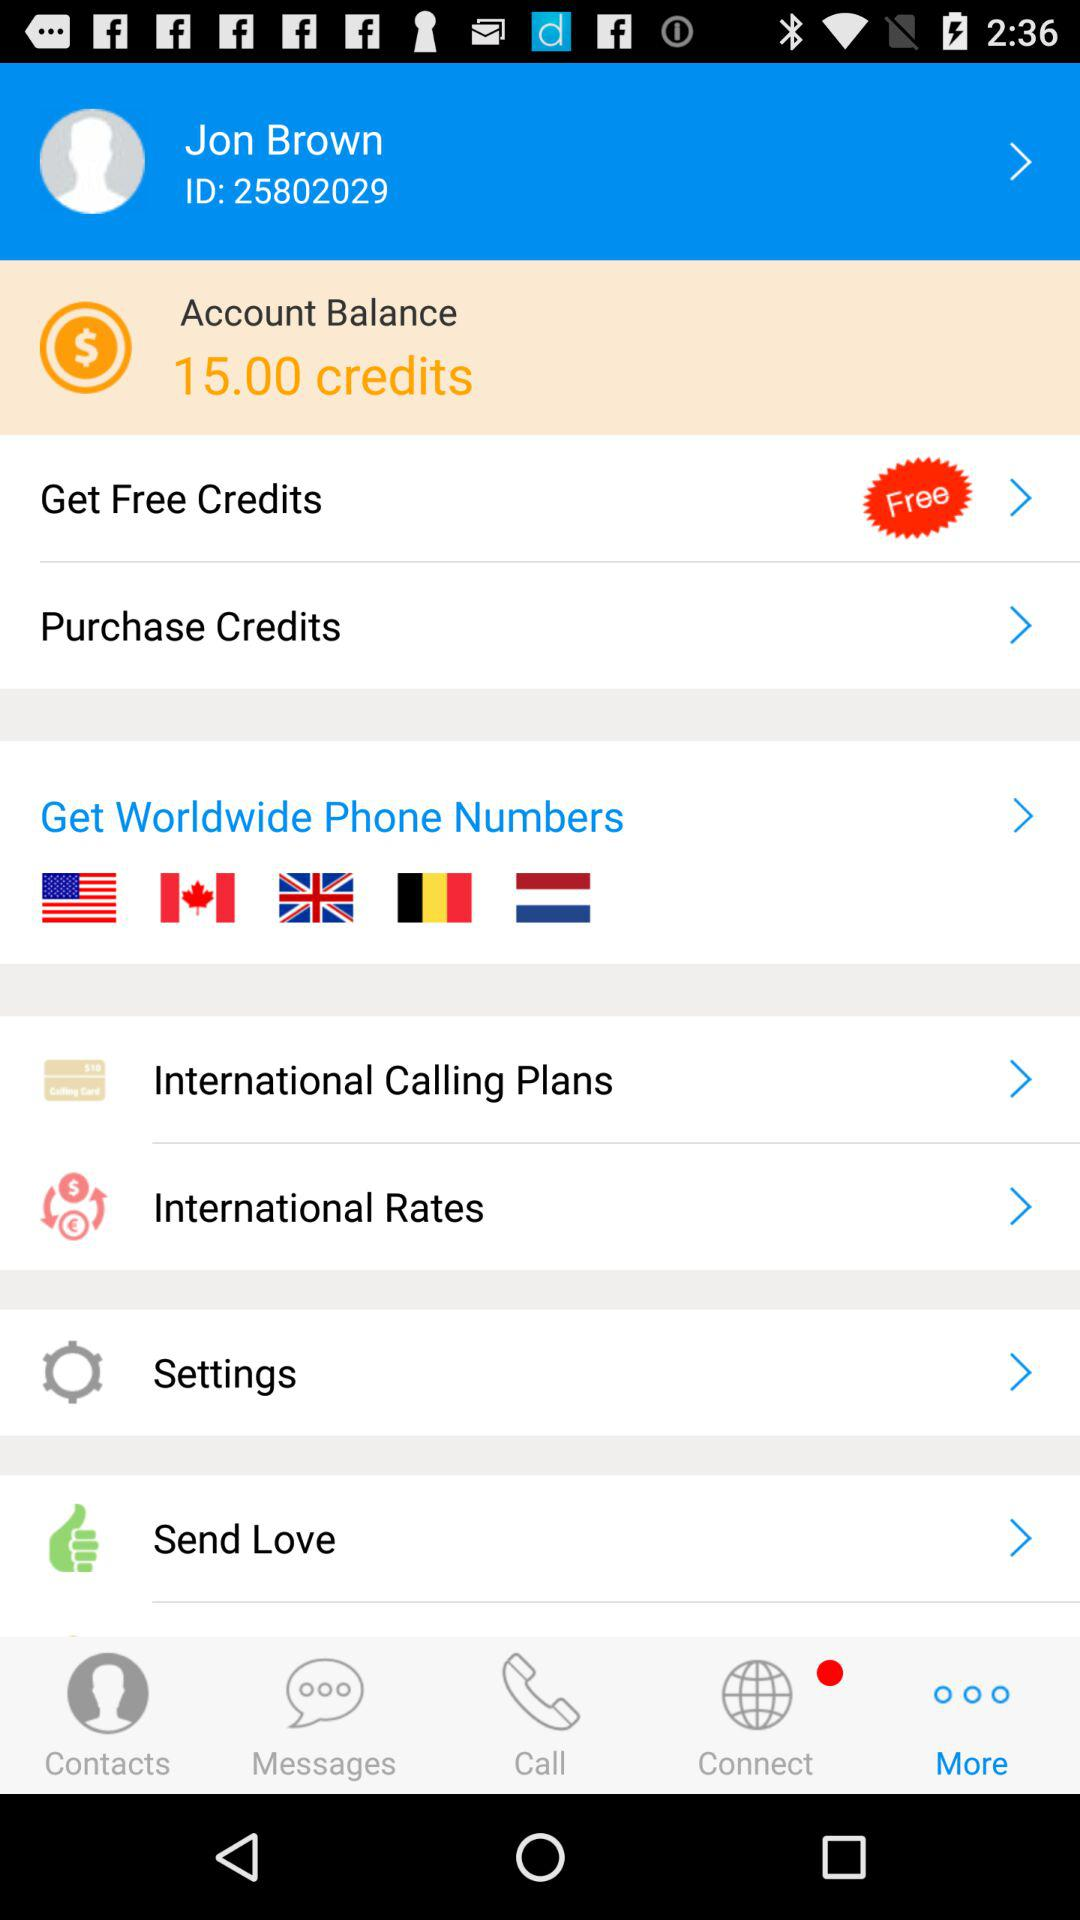How many more credits do I need to purchase to have 20 credits?
Answer the question using a single word or phrase. 5 